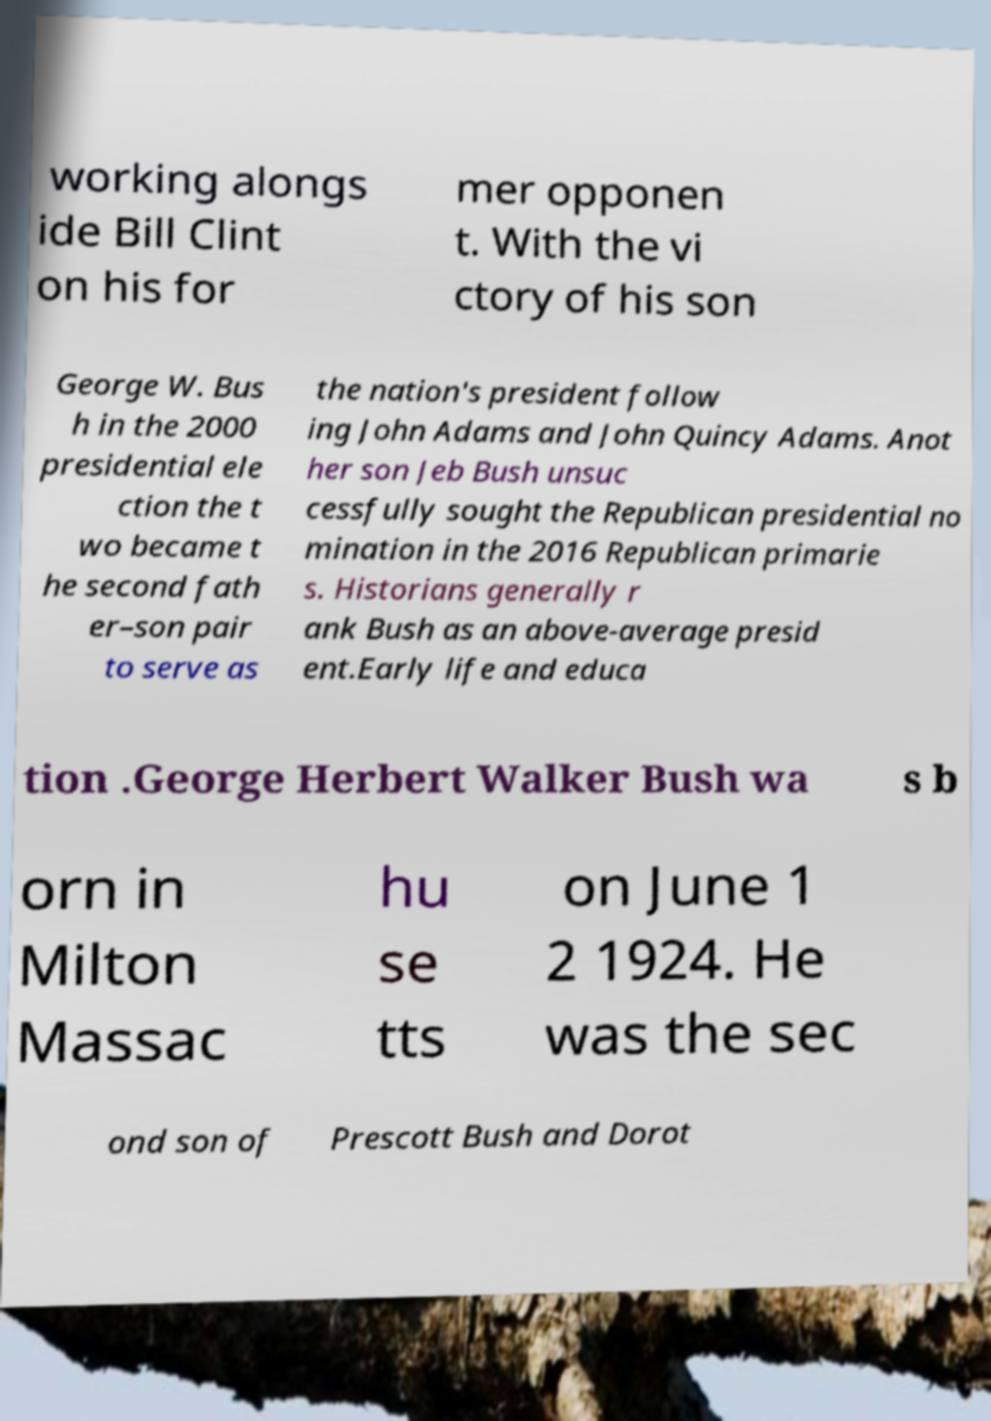Could you assist in decoding the text presented in this image and type it out clearly? working alongs ide Bill Clint on his for mer opponen t. With the vi ctory of his son George W. Bus h in the 2000 presidential ele ction the t wo became t he second fath er–son pair to serve as the nation's president follow ing John Adams and John Quincy Adams. Anot her son Jeb Bush unsuc cessfully sought the Republican presidential no mination in the 2016 Republican primarie s. Historians generally r ank Bush as an above-average presid ent.Early life and educa tion .George Herbert Walker Bush wa s b orn in Milton Massac hu se tts on June 1 2 1924. He was the sec ond son of Prescott Bush and Dorot 